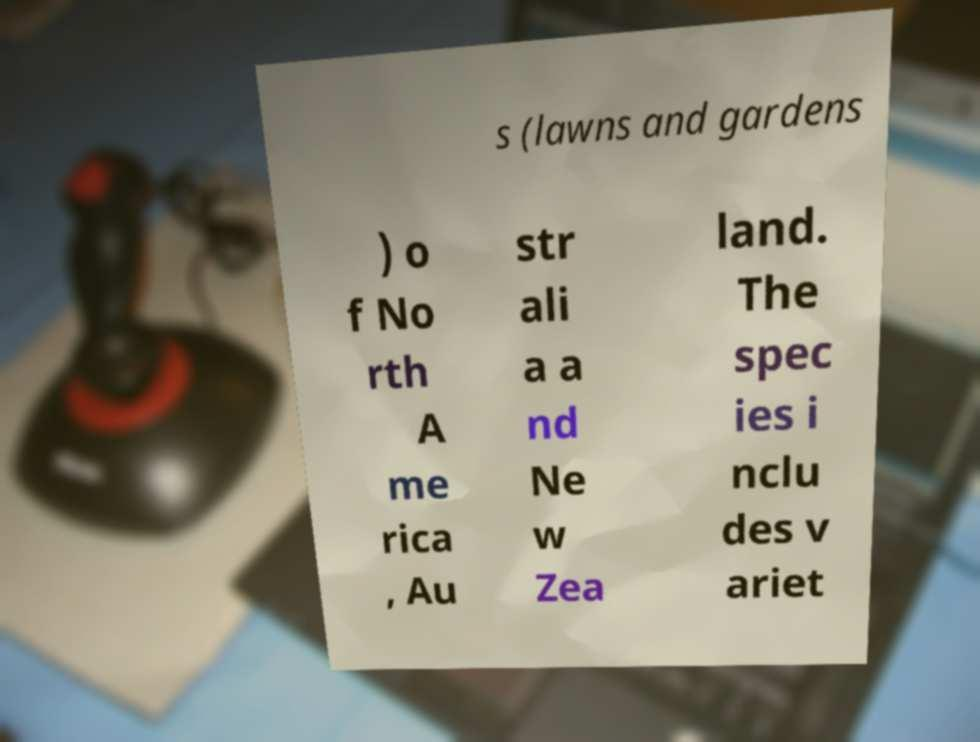I need the written content from this picture converted into text. Can you do that? s (lawns and gardens ) o f No rth A me rica , Au str ali a a nd Ne w Zea land. The spec ies i nclu des v ariet 